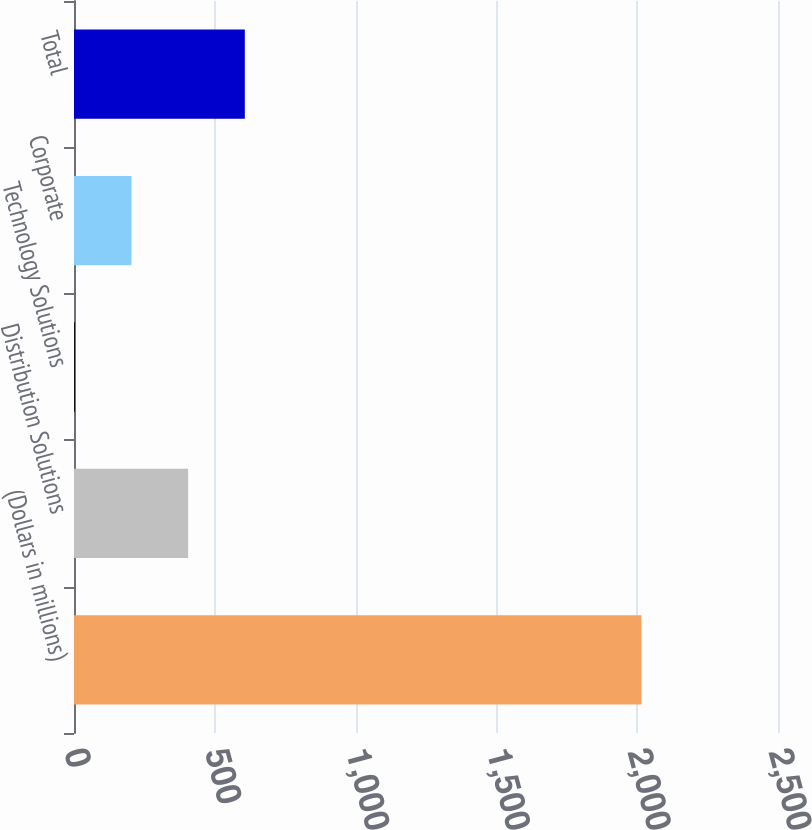<chart> <loc_0><loc_0><loc_500><loc_500><bar_chart><fcel>(Dollars in millions)<fcel>Distribution Solutions<fcel>Technology Solutions<fcel>Corporate<fcel>Total<nl><fcel>2015<fcel>405.4<fcel>3<fcel>204.2<fcel>606.6<nl></chart> 